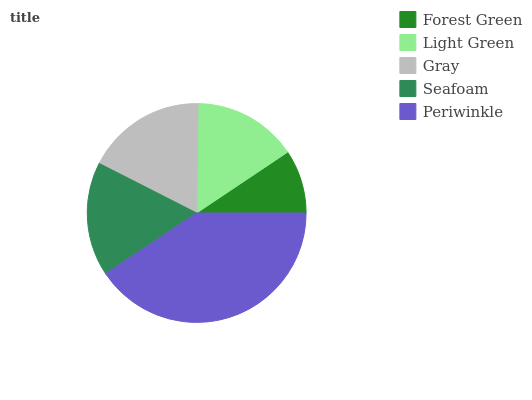Is Forest Green the minimum?
Answer yes or no. Yes. Is Periwinkle the maximum?
Answer yes or no. Yes. Is Light Green the minimum?
Answer yes or no. No. Is Light Green the maximum?
Answer yes or no. No. Is Light Green greater than Forest Green?
Answer yes or no. Yes. Is Forest Green less than Light Green?
Answer yes or no. Yes. Is Forest Green greater than Light Green?
Answer yes or no. No. Is Light Green less than Forest Green?
Answer yes or no. No. Is Seafoam the high median?
Answer yes or no. Yes. Is Seafoam the low median?
Answer yes or no. Yes. Is Periwinkle the high median?
Answer yes or no. No. Is Forest Green the low median?
Answer yes or no. No. 